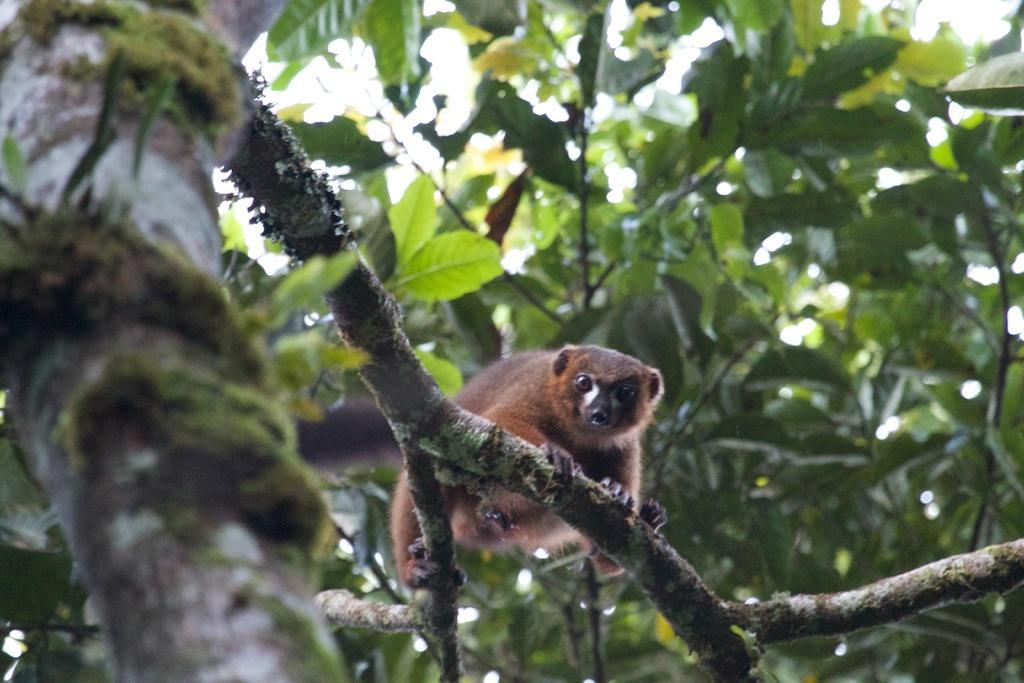Can you describe this image briefly? In this image we can see an animal on the tree branch and we can see some leaves in the background. 